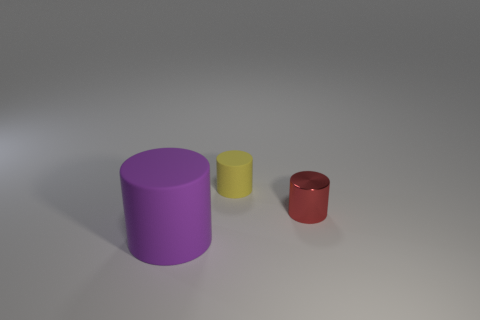Add 2 big brown matte objects. How many objects exist? 5 Subtract all purple cylinders. How many cylinders are left? 2 Subtract all small cylinders. How many cylinders are left? 1 Add 2 small yellow objects. How many small yellow objects are left? 3 Add 2 small yellow things. How many small yellow things exist? 3 Subtract 0 gray cylinders. How many objects are left? 3 Subtract all gray cylinders. Subtract all purple balls. How many cylinders are left? 3 Subtract all red balls. How many blue cylinders are left? 0 Subtract all purple matte things. Subtract all small cylinders. How many objects are left? 0 